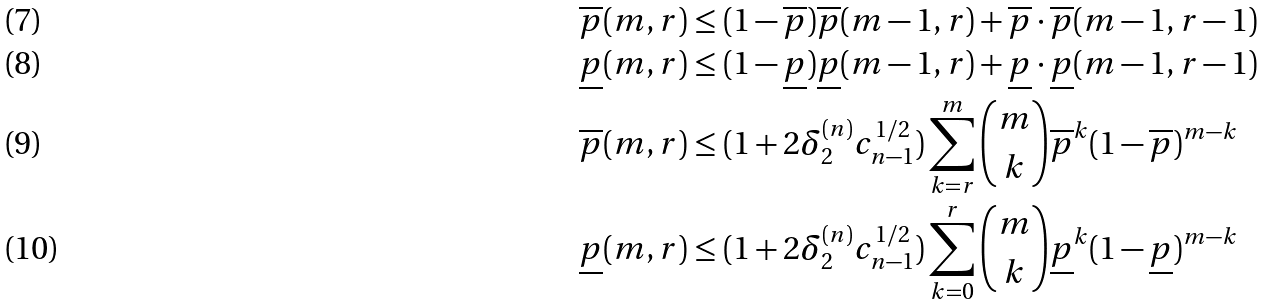<formula> <loc_0><loc_0><loc_500><loc_500>\overline { p } ( m , r ) & \leq ( 1 - \overline { p } ) \overline { p } ( m - 1 , r ) + \overline { p } \cdot \overline { p } ( m - 1 , r - 1 ) \\ \underline { p } ( m , r ) & \leq ( 1 - \underline { p } ) \underline { p } ( m - 1 , r ) + \underline { p } \cdot \underline { p } ( m - 1 , r - 1 ) \\ \overline { p } ( m , r ) & \leq ( 1 + 2 \delta ^ { ( n ) } _ { 2 } c _ { n - 1 } ^ { 1 / 2 } ) \sum _ { k = r } ^ { m } \binom { m } { k } \overline { p } ^ { k } ( 1 - \overline { p } ) ^ { m - k } \\ \underline { p } ( m , r ) & \leq ( 1 + 2 \delta ^ { ( n ) } _ { 2 } c _ { n - 1 } ^ { 1 / 2 } ) \sum _ { k = 0 } ^ { r } \binom { m } { k } \underline { p } ^ { k } ( 1 - \underline { p } ) ^ { m - k }</formula> 